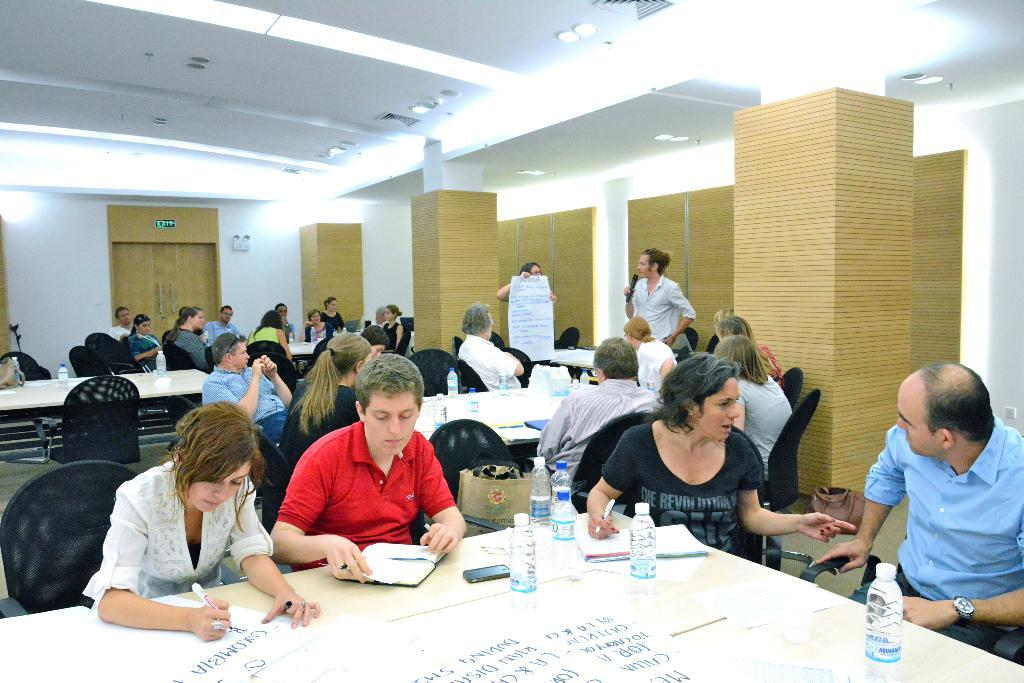How many people are sitting on the chair in the image? There is a group of people sitting on a chair in the image. What objects can be seen on the table in the image? There are bottles and papers on a table in the image. What architectural features can be seen in the background of the image? There is a pillar, a wall, and a door in the background of the image. What color is the umbrella hanging from the swing in the image? There is no umbrella or swing present in the image. How many people are sitting on the swing in the image? There is no swing present in the image, so it is not possible to answer that question. 